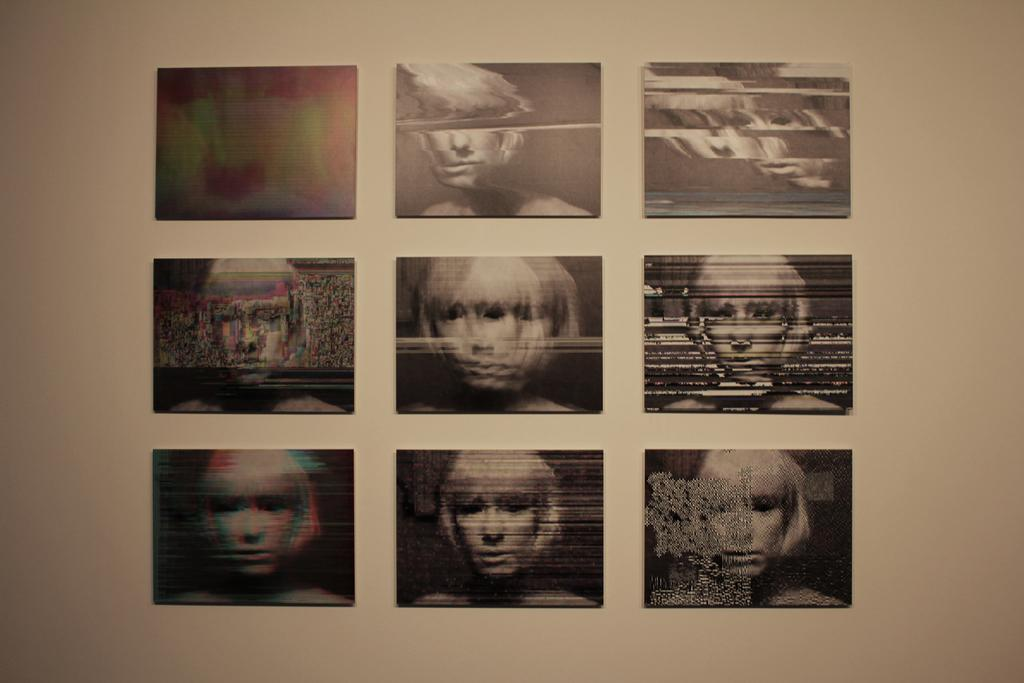How many frames are present in the image? There are nine frames in the image. Where are the frames located? The frames are attached to the wall. How are the frames arranged? The frames are arranged in an order. What can be seen in each frame? Each frame contains a picture of a person's face. What type of property is depicted in the frames? The frames do not depict any property; they contain pictures of people's faces. 